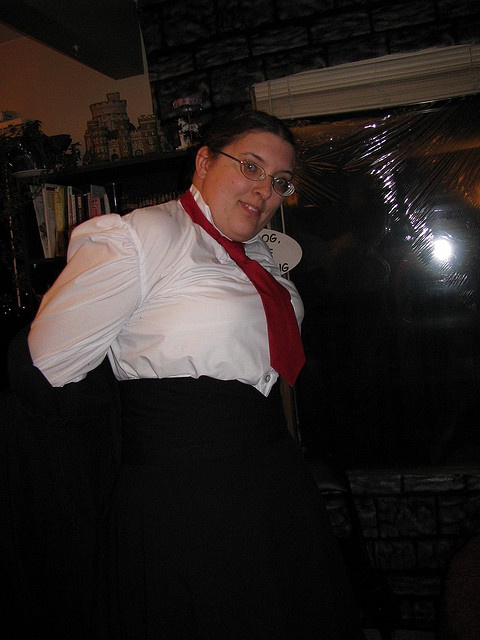Describe the objects in this image and their specific colors. I can see people in black, darkgray, and maroon tones, tie in black, maroon, gray, and darkgray tones, book in black, maroon, and gray tones, and book in black, maroon, and gray tones in this image. 